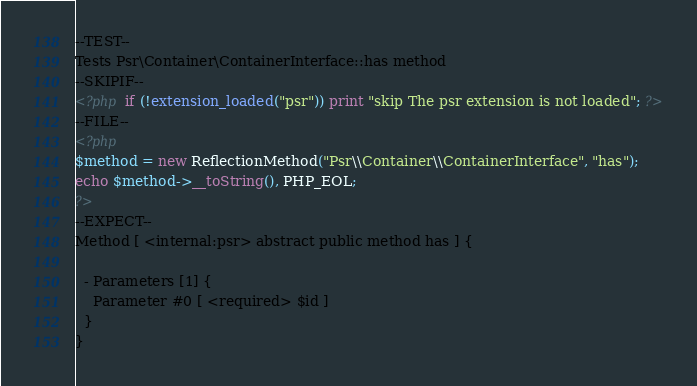<code> <loc_0><loc_0><loc_500><loc_500><_PHP_>--TEST--
Tests Psr\Container\ContainerInterface::has method
--SKIPIF--
<?php if (!extension_loaded("psr")) print "skip The psr extension is not loaded"; ?>
--FILE--
<?php
$method = new ReflectionMethod("Psr\\Container\\ContainerInterface", "has");
echo $method->__toString(), PHP_EOL;
?>
--EXPECT--
Method [ <internal:psr> abstract public method has ] {

  - Parameters [1] {
    Parameter #0 [ <required> $id ]
  }
}
</code> 